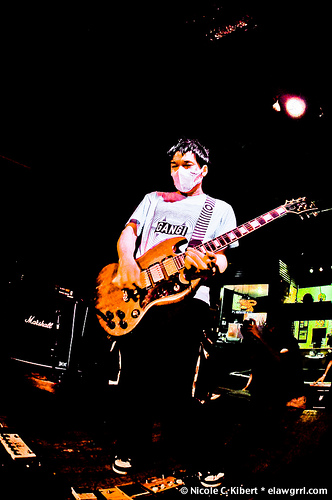<image>
Can you confirm if the guitar is on the mask? No. The guitar is not positioned on the mask. They may be near each other, but the guitar is not supported by or resting on top of the mask. 